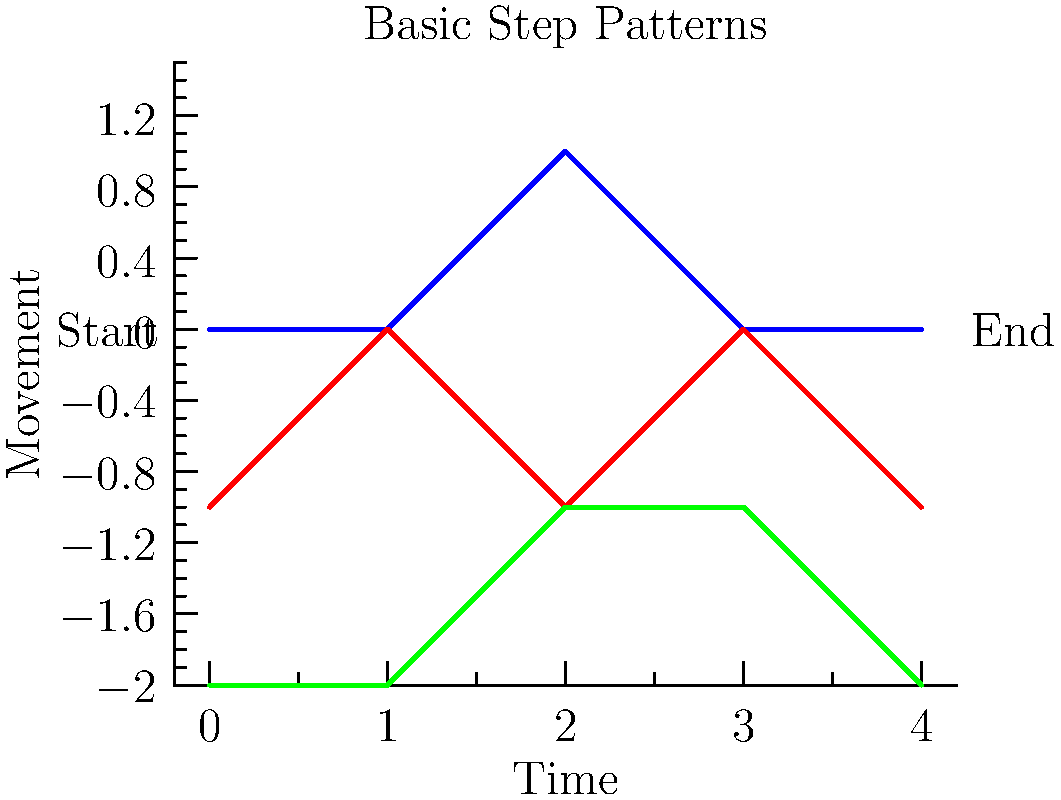In the flow diagram above, which swing dance style demonstrates the most consistent up-and-down movement pattern, reminiscent of the lively bounce in classic swing tunes like Benny Goodman's "Sing, Sing, Sing"? To answer this question, we need to analyze the movement patterns of each swing dance style shown in the flow diagram:

1. Lindy Hop (blue line):
   - Starts low, stays low, goes up, then down, and ends low
   - Pattern: Low-Low-High-Low-Low

2. East Coast Swing (red line):
   - Starts low, goes up, down, up, and ends low
   - Pattern: Low-High-Low-High-Low

3. West Coast Swing (green line):
   - Starts low, stays low, goes up, stays up, and ends low
   - Pattern: Low-Low-High-High-Low

The most consistent up-and-down movement would be represented by a regular alternation between low and high points. Among these three styles, the East Coast Swing shows the most consistent alternating pattern, with each step alternating between low and high positions.

This regular up-and-down movement in East Coast Swing is indeed reminiscent of the lively, bouncy feel often found in classic swing tunes like "Sing, Sing, Sing" by Benny Goodman. The dance's rhythm closely mirrors the energetic and buoyant nature of such music, making it a perfect match for the question's description.
Answer: East Coast Swing 